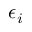Convert formula to latex. <formula><loc_0><loc_0><loc_500><loc_500>\epsilon _ { i }</formula> 